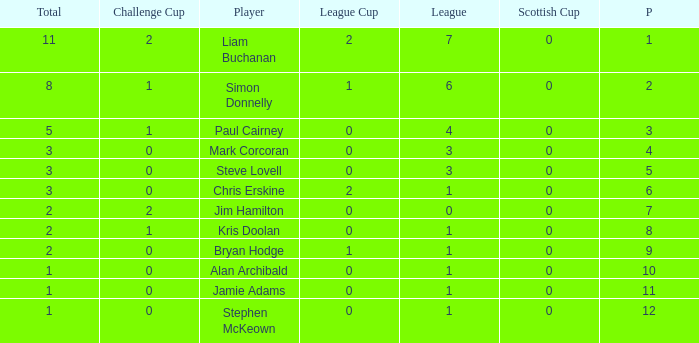What is bryan hodge's player number 1.0. 